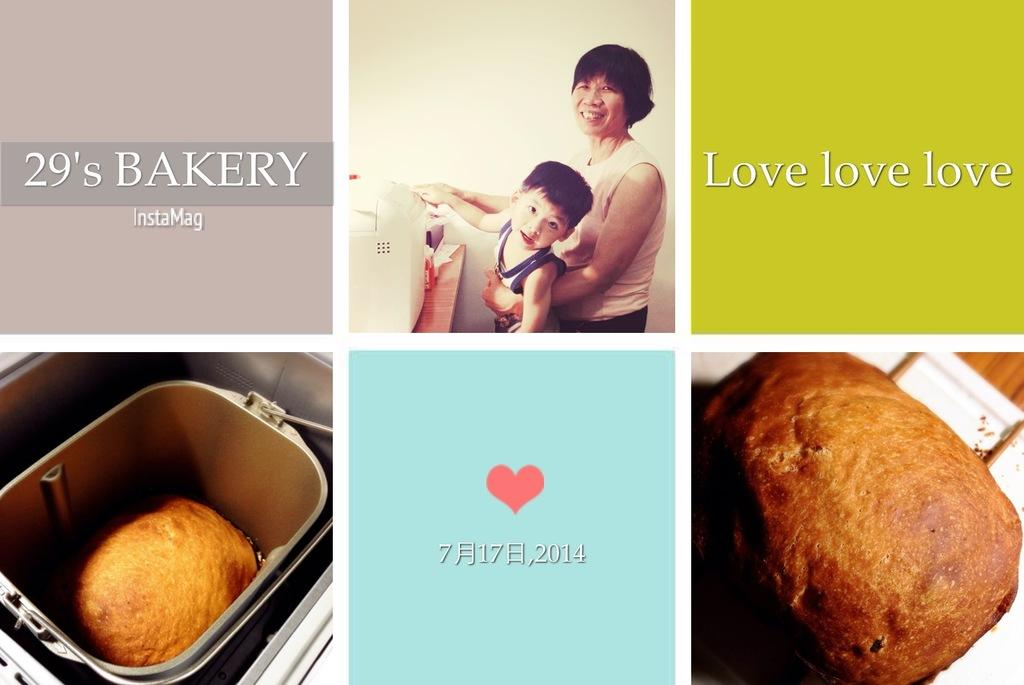Provide a one-sentence caption for the provided image. A place called the 29's Bakery wants to show love. 